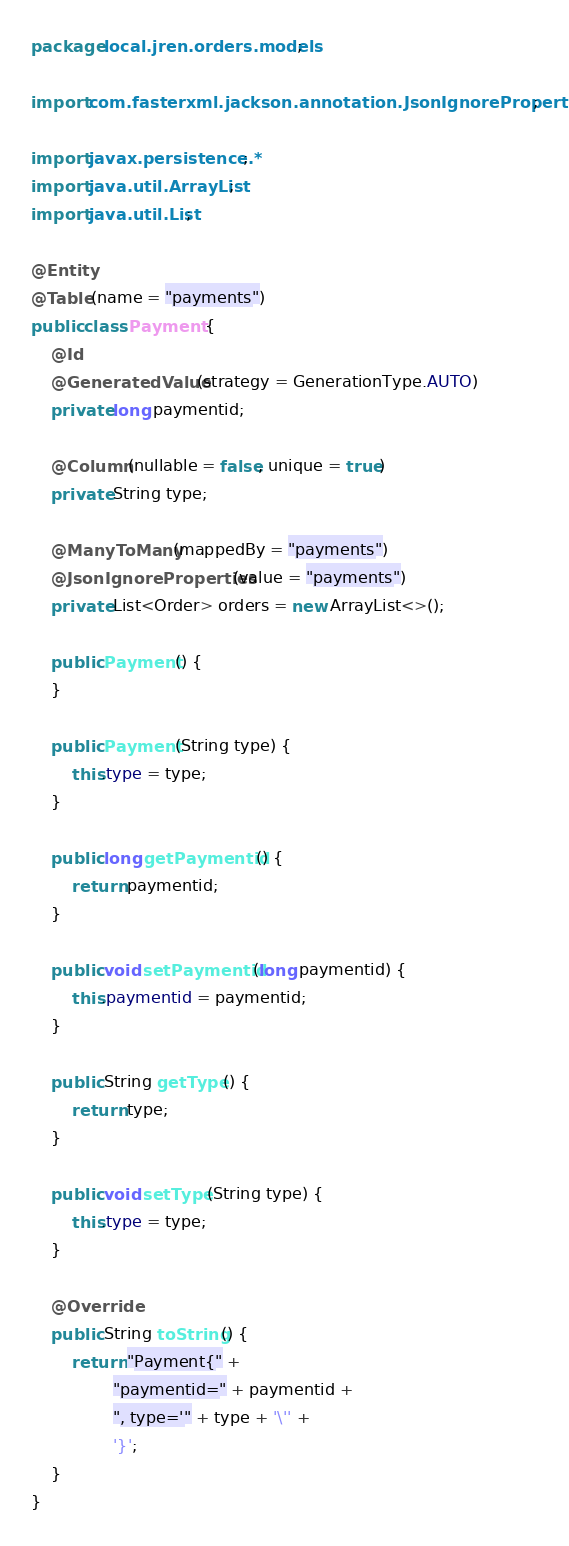<code> <loc_0><loc_0><loc_500><loc_500><_Java_>package local.jren.orders.models;

import com.fasterxml.jackson.annotation.JsonIgnoreProperties;

import javax.persistence.*;
import java.util.ArrayList;
import java.util.List;

@Entity
@Table(name = "payments")
public class Payment {
    @Id
    @GeneratedValue(strategy = GenerationType.AUTO)
    private long paymentid;

    @Column(nullable = false, unique = true)
    private String type;

    @ManyToMany(mappedBy = "payments")
    @JsonIgnoreProperties(value = "payments")
    private List<Order> orders = new ArrayList<>();

    public Payment() {
    }

    public Payment(String type) {
        this.type = type;
    }

    public long getPaymentid() {
        return paymentid;
    }

    public void setPaymentid(long paymentid) {
        this.paymentid = paymentid;
    }

    public String getType() {
        return type;
    }

    public void setType(String type) {
        this.type = type;
    }

    @Override
    public String toString() {
        return "Payment{" +
                "paymentid=" + paymentid +
                ", type='" + type + '\'' +
                '}';
    }
}
</code> 